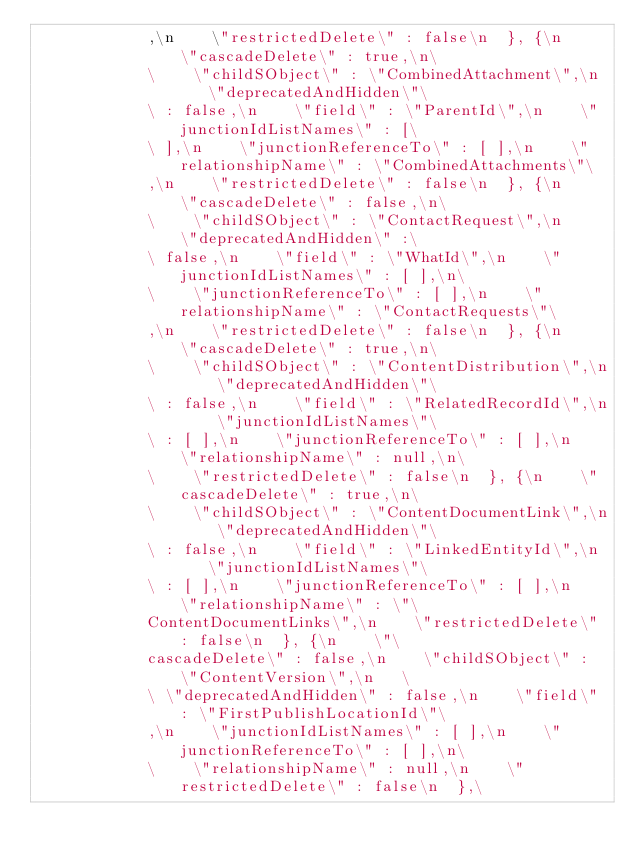<code> <loc_0><loc_0><loc_500><loc_500><_YAML_>            ,\n    \"restrictedDelete\" : false\n  }, {\n    \"cascadeDelete\" : true,\n\
            \    \"childSObject\" : \"CombinedAttachment\",\n    \"deprecatedAndHidden\"\
            \ : false,\n    \"field\" : \"ParentId\",\n    \"junctionIdListNames\" : [\
            \ ],\n    \"junctionReferenceTo\" : [ ],\n    \"relationshipName\" : \"CombinedAttachments\"\
            ,\n    \"restrictedDelete\" : false\n  }, {\n    \"cascadeDelete\" : false,\n\
            \    \"childSObject\" : \"ContactRequest\",\n    \"deprecatedAndHidden\" :\
            \ false,\n    \"field\" : \"WhatId\",\n    \"junctionIdListNames\" : [ ],\n\
            \    \"junctionReferenceTo\" : [ ],\n    \"relationshipName\" : \"ContactRequests\"\
            ,\n    \"restrictedDelete\" : false\n  }, {\n    \"cascadeDelete\" : true,\n\
            \    \"childSObject\" : \"ContentDistribution\",\n    \"deprecatedAndHidden\"\
            \ : false,\n    \"field\" : \"RelatedRecordId\",\n    \"junctionIdListNames\"\
            \ : [ ],\n    \"junctionReferenceTo\" : [ ],\n    \"relationshipName\" : null,\n\
            \    \"restrictedDelete\" : false\n  }, {\n    \"cascadeDelete\" : true,\n\
            \    \"childSObject\" : \"ContentDocumentLink\",\n    \"deprecatedAndHidden\"\
            \ : false,\n    \"field\" : \"LinkedEntityId\",\n    \"junctionIdListNames\"\
            \ : [ ],\n    \"junctionReferenceTo\" : [ ],\n    \"relationshipName\" : \"\
            ContentDocumentLinks\",\n    \"restrictedDelete\" : false\n  }, {\n    \"\
            cascadeDelete\" : false,\n    \"childSObject\" : \"ContentVersion\",\n   \
            \ \"deprecatedAndHidden\" : false,\n    \"field\" : \"FirstPublishLocationId\"\
            ,\n    \"junctionIdListNames\" : [ ],\n    \"junctionReferenceTo\" : [ ],\n\
            \    \"relationshipName\" : null,\n    \"restrictedDelete\" : false\n  },\</code> 